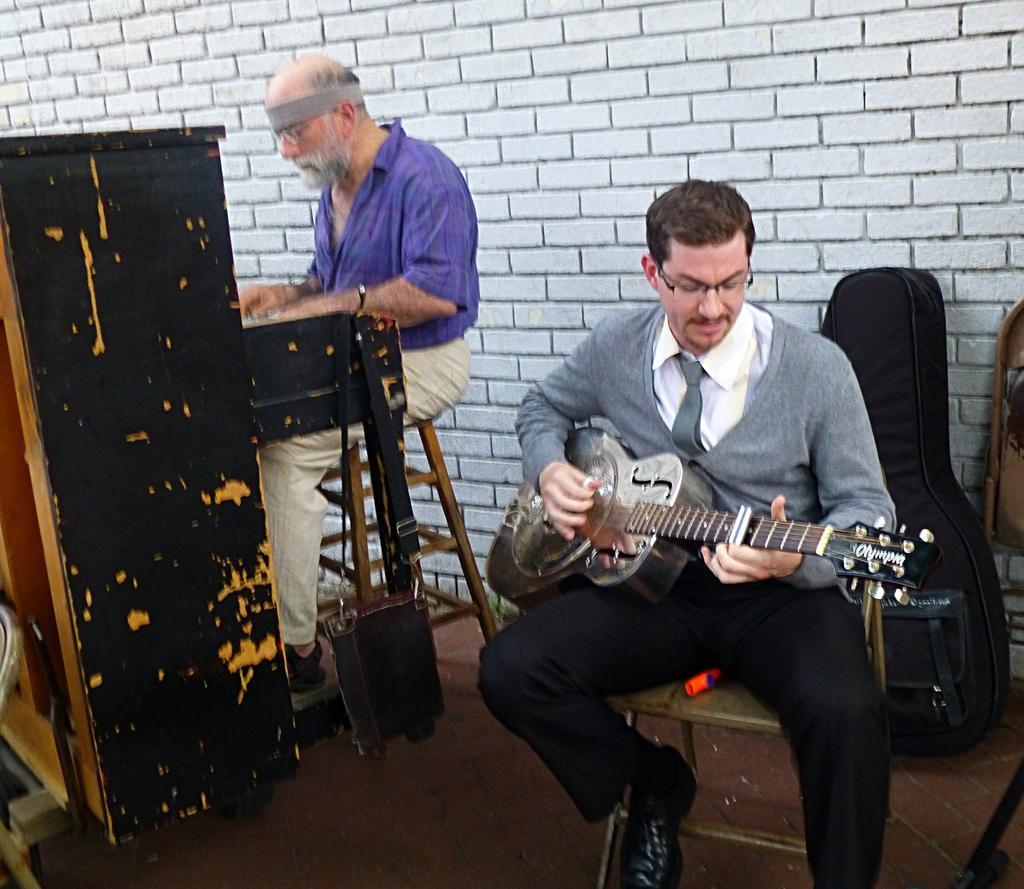How would you summarize this image in a sentence or two? In this picture there is a person sitting on the left playing the piano and another person sitting on the right playing the guitar 